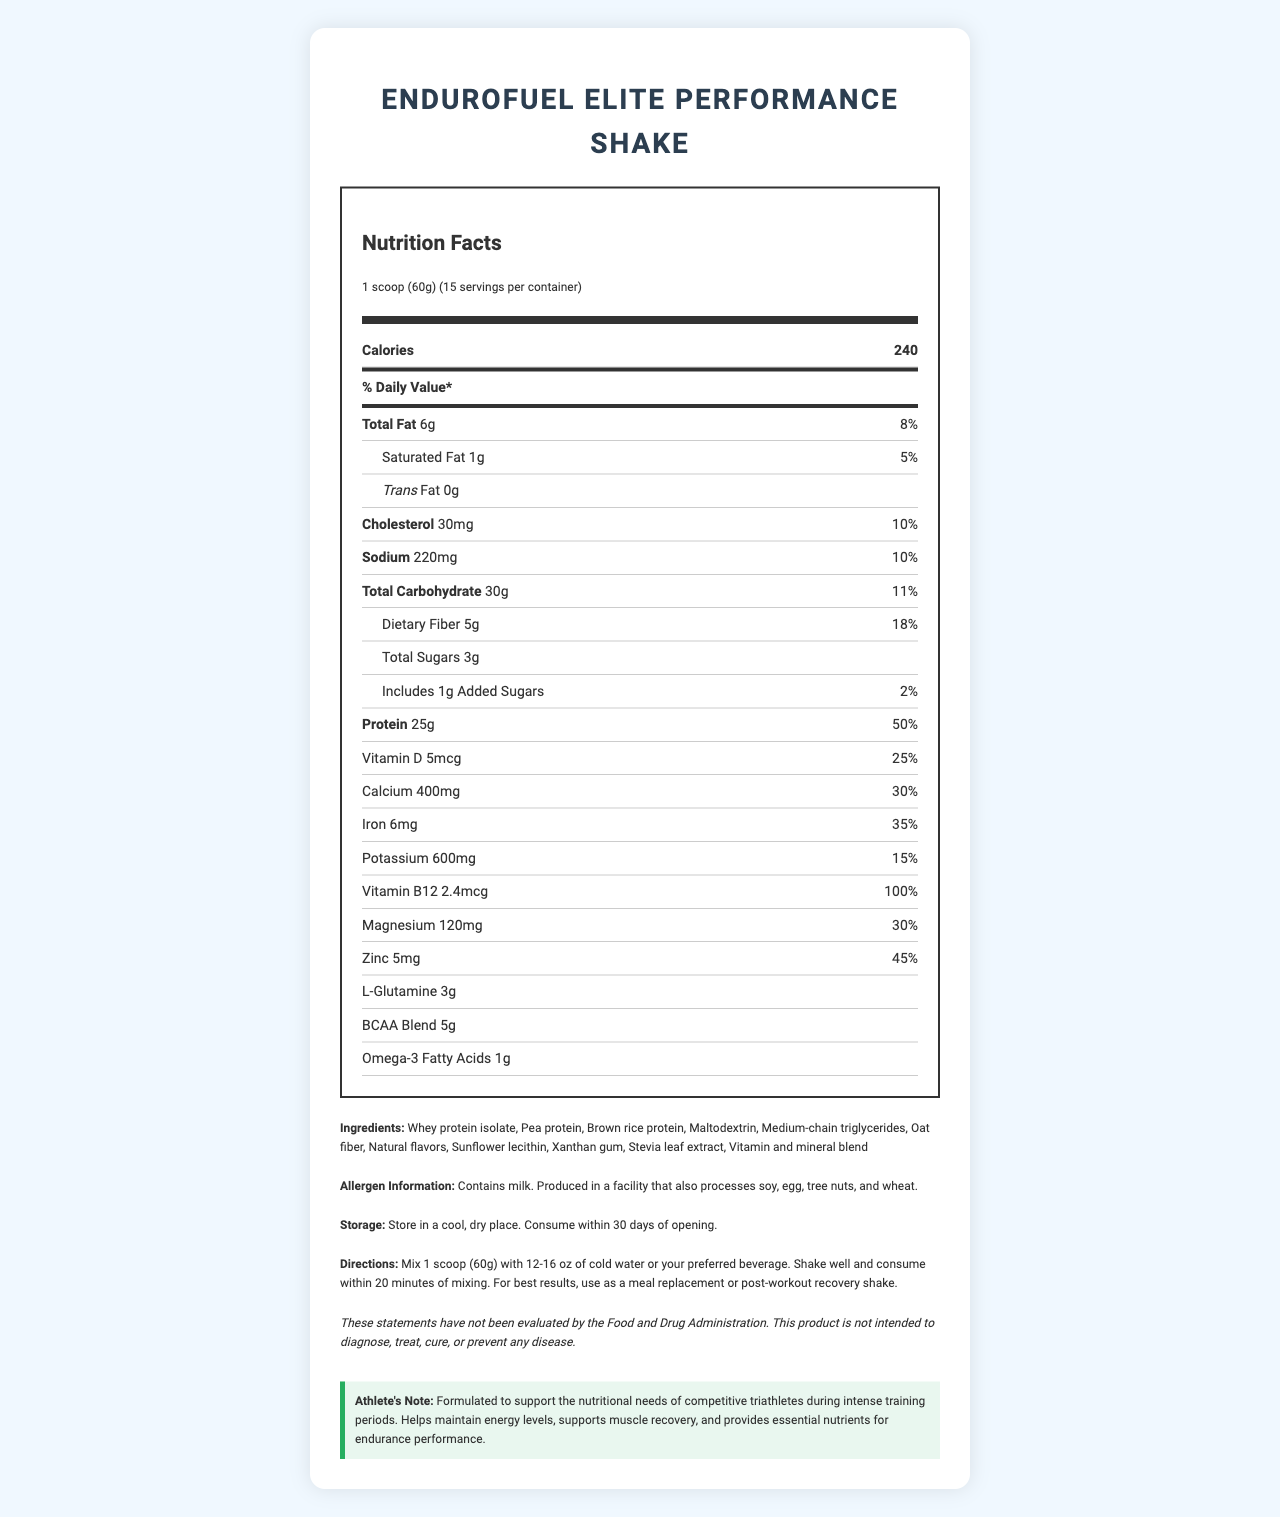how many calories are in one serving of EnduroFuel Elite Performance Shake? The label indicates that each serving contains 240 calories.
Answer: 240 how much protein does each serving provide? The label specifies that each serving includes 25 grams of protein.
Answer: 25g is this product safe for someone with a nut allergy? The allergen information indicates that the product is produced in a facility that also processes tree nuts.
Answer: No what is the percentage daily value of dietary fiber in one serving? The label states that each serving contains 18% of the daily value for dietary fiber.
Answer: 18% what are the primary proteins used in this shake? Under the ingredients list, the primary proteins are identified as whey protein isolate, pea protein, and brown rice protein.
Answer: Whey protein isolate, Pea protein, Brown rice protein how should the EnduroFuel Elite Performance Shake be stored? The storage instructions explicitly state to store in a cool, dry place and consume within 30 days of opening.
Answer: Store in a cool, dry place. Consume within 30 days of opening. what is the serving size for this meal replacement shake? The serving size is mentioned as 1 scoop, equivalent to 60 grams.
Answer: 1 scoop (60g) how many servings are in the container? A. 10 B. 15 C. 20 D. 25 The label indicates that there are 15 servings per container.
Answer: B. 15 which mineral is provided at 100% of its daily value in this shake? The nutrition facts state that Vitamin B12 is provided at 100% of the daily value per serving.
Answer: Vitamin B12 what is the total amount of sugars in one serving? A. 1g B. 2g C. 3g D. 4g The label shows that each serving contains 3 grams of total sugars.
Answer: C. 3g does the product include any added sugars? The label specifies that it includes 1g of added sugars.
Answer: Yes are there any omega-3 fatty acids in this product? The nutrition facts list includes 1 gram of omega-3 fatty acids.
Answer: Yes what is the main idea of this document? The document provides comprehensive nutritional information about a specific meal replacement shake formulated for intense training days, focusing on details relevant to athletes' dietary needs.
Answer: The document is a Nutrition Facts Label for EnduroFuel Elite Performance Shake, detailing the serving size, ingredients, nutritional content, daily values, allergen information, storage instructions, directions for use, and a note specifically for athletes. what are the main benefits of using this product for triathletes? The athlete's note indicates that the product is formulated to support the nutritional needs of competitive triathletes, with benefits including energy maintenance, muscle recovery support, and essential nutrient provision.
Answer: Helps maintain energy levels, supports muscle recovery, and provides essential nutrients for endurance performance. does this product contain any trans fat? The label states that the product contains 0g of trans fat.
Answer: No how should this product be consumed for best results? The directions specify mixing a scoop with water or another beverage, shaking well, and consuming promptly, or using it as a meal replacement or recovery shake.
Answer: Mix 1 scoop (60g) with 12-16 oz of cold water or preferred beverage. Shake well and consume within 20 minutes of mixing. Use as a meal replacement or post-workout recovery shake. what is the exact amount of L-Glutamine in one serving? The label indicates that each serving contains 3 grams of L-Glutamine.
Answer: 3g is the EnduroFuel Elite Performance Shake intended to cure diseases? The disclaimer clearly states that the product is not intended to diagnose, treat, cure, or prevent any disease.
Answer: No is this product formulated for intense training days? The athlete's note specifies that it is formulated for intense training periods.
Answer: Yes what are the other two nutrients included alongside L-Glutamine? The label lists both BCAA blend and Omega-3 fatty acids along with L-Glutamine.
Answer: BCAA Blend, Omega-3 Fatty Acids who is the president of the company that manufactures this shake? The document does not provide any information regarding the president or company leadership.
Answer: Cannot be determined 